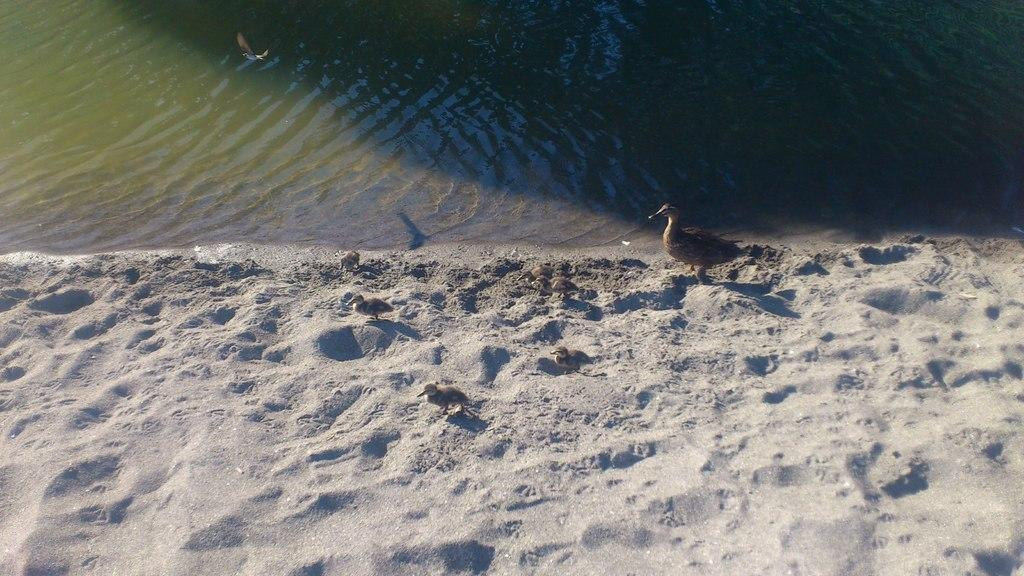What type of natural environment is depicted in the image? The image contains soil and water, which suggests a natural environment such as a pond or a marsh. What type of animals can be seen in the image? There are birds visible in the image. Can you describe the setting where the birds are located? The birds are located in a natural environment that includes soil and water. What type of furniture can be seen in the image? There is no furniture present in the image; it features a natural environment with soil, water, and birds. How many snails are visible in the image? There are no snails visible in the image; it features a natural environment with soil, water, and birds. 